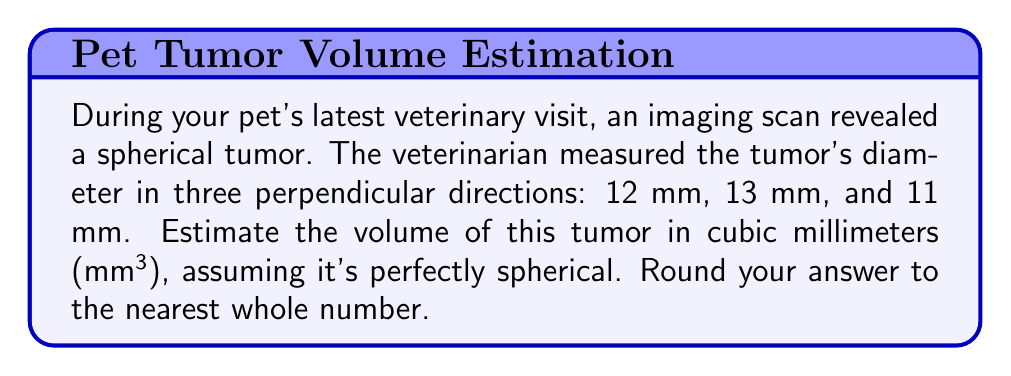Show me your answer to this math problem. To estimate the volume of a spherical tumor, we'll use the formula for the volume of a sphere:

$$V = \frac{4}{3}\pi r^3$$

Where $V$ is the volume and $r$ is the radius.

Given measurements:
- Diameter 1: 12 mm
- Diameter 2: 13 mm
- Diameter 3: 11 mm

Step 1: Calculate the average diameter
$$ \text{Average diameter} = \frac{12 + 13 + 11}{3} = 12 \text{ mm} $$

Step 2: Calculate the radius
$$ r = \frac{\text{Average diameter}}{2} = \frac{12}{2} = 6 \text{ mm} $$

Step 3: Apply the volume formula
$$ V = \frac{4}{3}\pi r^3 = \frac{4}{3}\pi (6)^3 $$

Step 4: Calculate the result
$$ V = \frac{4}{3}\pi (216) \approx 904.7786842 \text{ mm}^3 $$

Step 5: Round to the nearest whole number
$$ V \approx 905 \text{ mm}^3 $$
Answer: 905 mm³ 